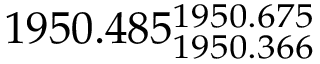<formula> <loc_0><loc_0><loc_500><loc_500>1 9 5 0 . 4 8 5 _ { 1 9 5 0 . 3 6 6 } ^ { 1 9 5 0 . 6 7 5 }</formula> 